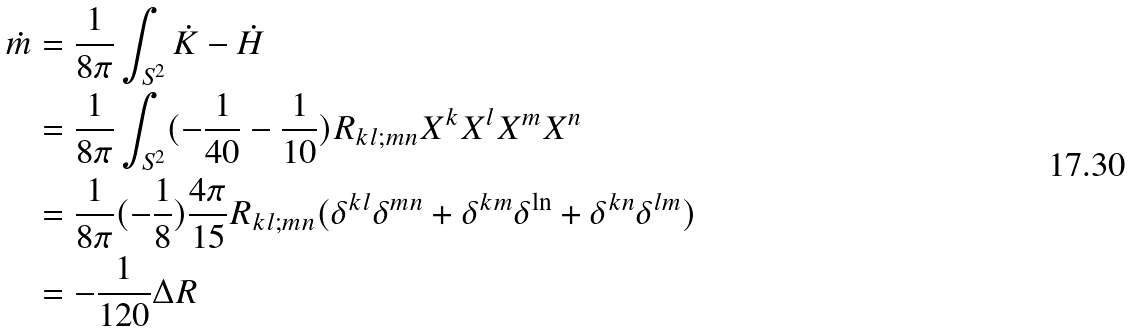Convert formula to latex. <formula><loc_0><loc_0><loc_500><loc_500>\dot { m } & = \frac { 1 } { 8 \pi } \int _ { S ^ { 2 } } \dot { K } - \dot { H } \\ & = \frac { 1 } { 8 \pi } \int _ { S ^ { 2 } } ( - \frac { 1 } { 4 0 } - \frac { 1 } { 1 0 } ) R _ { k l ; m n } X ^ { k } X ^ { l } X ^ { m } X ^ { n } \\ & = \frac { 1 } { 8 \pi } ( - \frac { 1 } { 8 } ) \frac { 4 \pi } { 1 5 } R _ { k l ; m n } ( \delta ^ { k l } \delta ^ { m n } + \delta ^ { k m } \delta ^ { \ln } + \delta ^ { k n } \delta ^ { l m } ) \\ & = - \frac { 1 } { 1 2 0 } \Delta R</formula> 